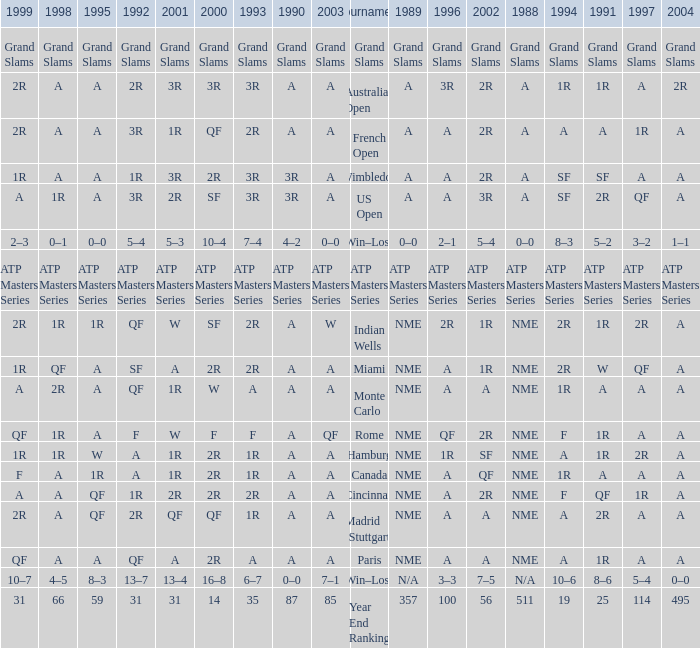What shows for 1995 when 1996 shows grand slams? Grand Slams. 